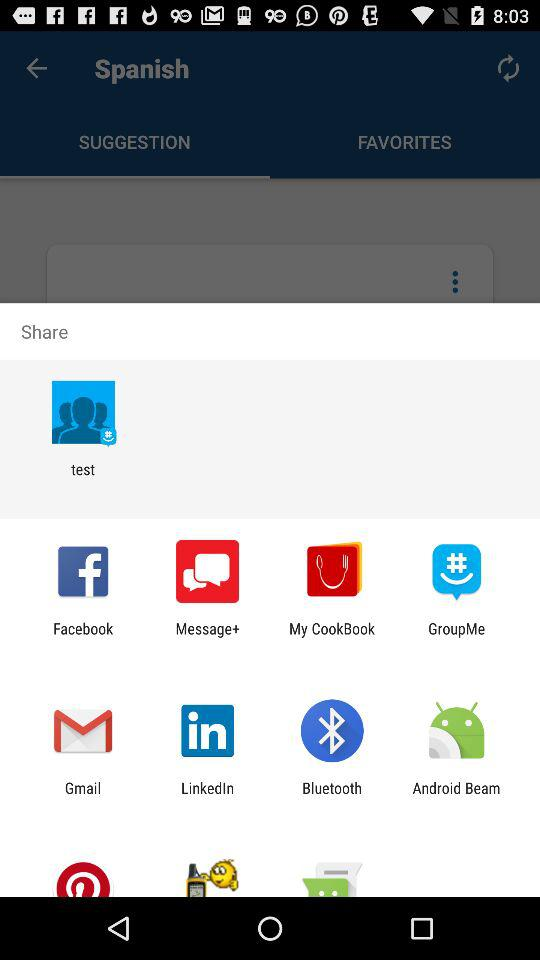How many items are in "FAVORITES"?
When the provided information is insufficient, respond with <no answer>. <no answer> 